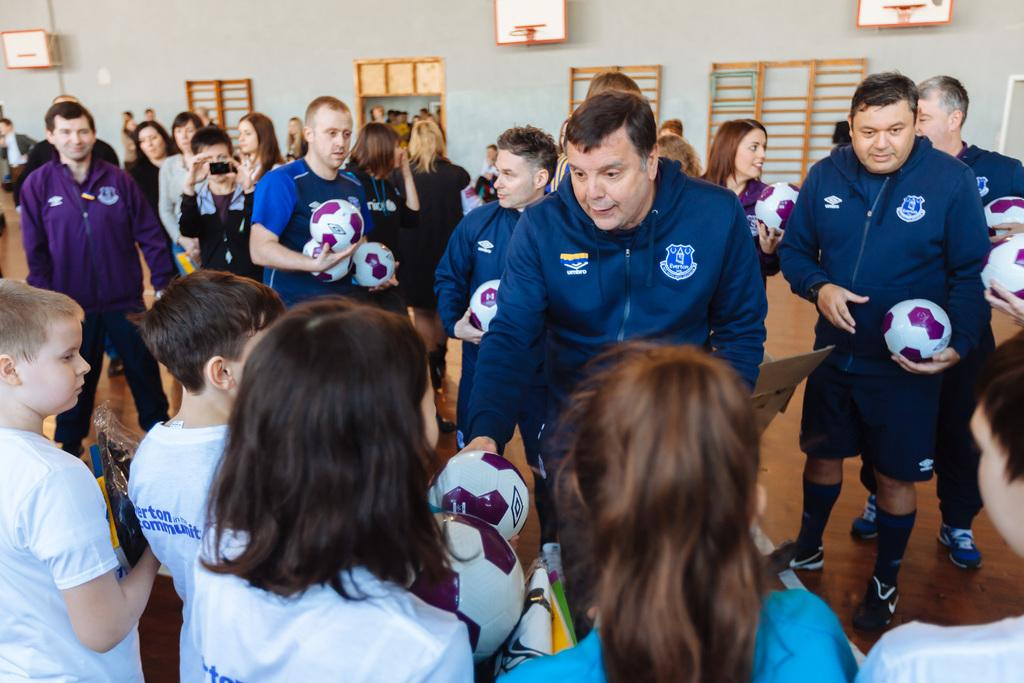What is the main subject of the image? The main subject of the image is a group of people. What are the people holding in the image? The people are holding a ball in the image. What architectural features can be seen in the background of the image? There is a door and a window in the background of the image. What type of stitch is being used to sew the ball in the image? There is no indication in the image that the ball is being sewn or that any stitching is involved. --- Facts: 1. There is a car in the image. 2. The car is parked on the street. 3. There are trees on the side of the street. 4. The sky is visible in the image. Absurd Topics: dance, melody, sculpture Conversation: What is the main subject of the image? The main subject of the image is a car. Where is the car located in the image? The car is parked on the street in the image. What type of vegetation can be seen on the side of the street? There are trees on the side of the street in the image. What is visible in the background of the image? The sky is visible in the image. Reasoning: Let's think step by step in order to produce the conversation. We start by identifying the main subject of the image, which is the car. Next, we describe the location of the car, which is parked on the street. Then, we observe the surrounding environment, noting the presence of trees and the sky. Absurd Question/Answer: What type of dance is being performed by the car in the image? There is no indication in the image that the car is performing any dance or movement. --- Facts: 1. There is a person sitting on a bench in the image. 2. The person is reading a book. 3. There is a tree behind the bench. 4. The sky 